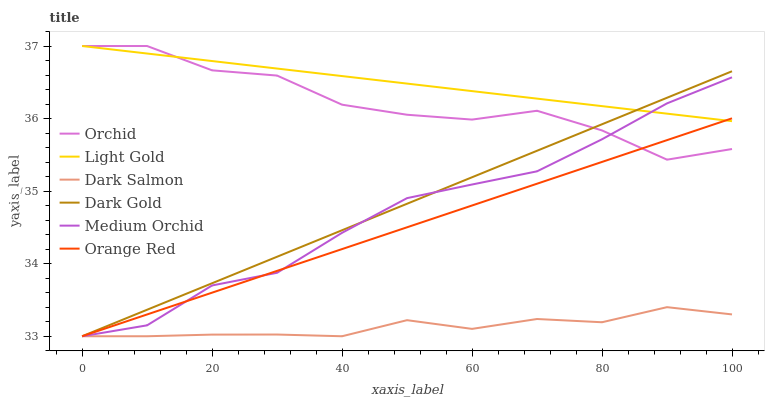Does Dark Salmon have the minimum area under the curve?
Answer yes or no. Yes. Does Light Gold have the maximum area under the curve?
Answer yes or no. Yes. Does Medium Orchid have the minimum area under the curve?
Answer yes or no. No. Does Medium Orchid have the maximum area under the curve?
Answer yes or no. No. Is Light Gold the smoothest?
Answer yes or no. Yes. Is Orchid the roughest?
Answer yes or no. Yes. Is Medium Orchid the smoothest?
Answer yes or no. No. Is Medium Orchid the roughest?
Answer yes or no. No. Does Dark Gold have the lowest value?
Answer yes or no. Yes. Does Light Gold have the lowest value?
Answer yes or no. No. Does Orchid have the highest value?
Answer yes or no. Yes. Does Medium Orchid have the highest value?
Answer yes or no. No. Is Dark Salmon less than Light Gold?
Answer yes or no. Yes. Is Light Gold greater than Dark Salmon?
Answer yes or no. Yes. Does Medium Orchid intersect Orange Red?
Answer yes or no. Yes. Is Medium Orchid less than Orange Red?
Answer yes or no. No. Is Medium Orchid greater than Orange Red?
Answer yes or no. No. Does Dark Salmon intersect Light Gold?
Answer yes or no. No. 